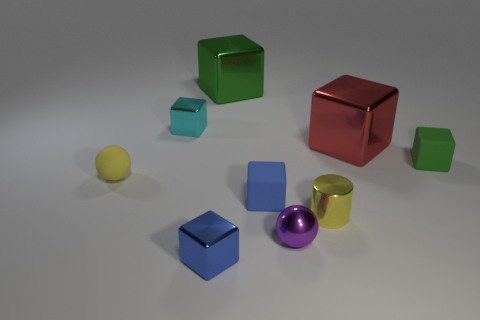There is a small yellow rubber ball; are there any tiny shiny objects in front of it?
Your response must be concise. Yes. How many red objects are either tiny rubber spheres or metal objects?
Provide a succinct answer. 1. Is the material of the purple thing the same as the green object on the right side of the large red shiny cube?
Provide a succinct answer. No. The red metal object that is the same shape as the green metal thing is what size?
Your answer should be compact. Large. What is the material of the tiny yellow cylinder?
Provide a short and direct response. Metal. There is a yellow object that is to the left of the small thing that is behind the small matte block to the right of the cylinder; what is it made of?
Make the answer very short. Rubber. There is a matte block that is to the left of the tiny yellow metal object; is it the same size as the rubber object on the left side of the cyan metal block?
Provide a short and direct response. Yes. How many other things are there of the same material as the cyan thing?
Make the answer very short. 5. How many matte things are tiny green cubes or blue objects?
Ensure brevity in your answer.  2. Is the number of tiny green cubes less than the number of big yellow shiny balls?
Provide a succinct answer. No. 